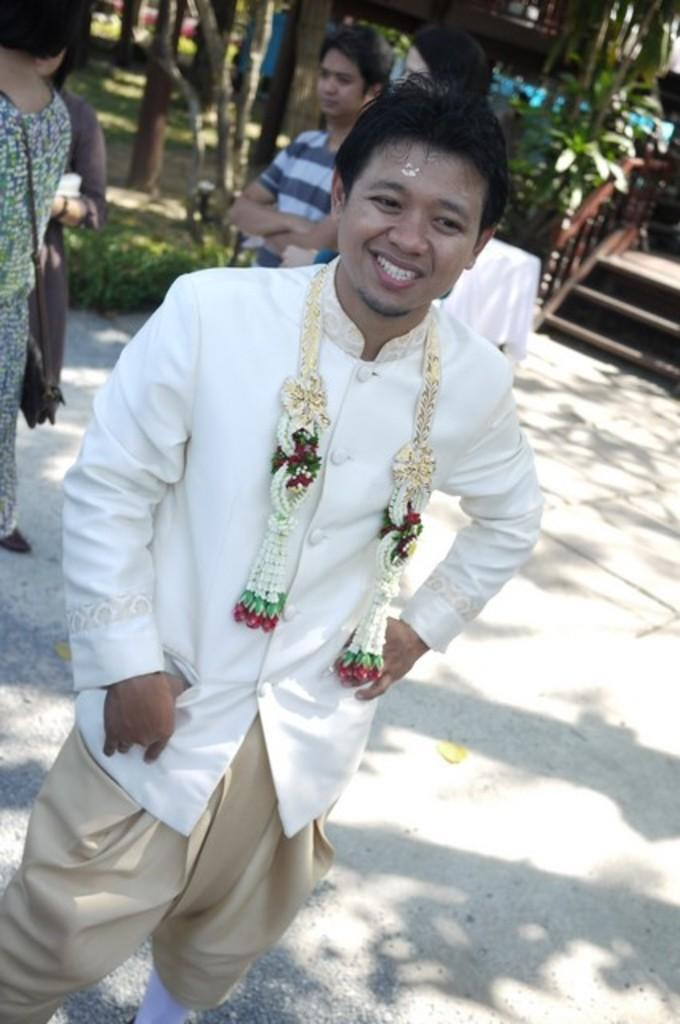What are the persons in the image wearing? The persons in the image are wearing clothes. What can be seen in the top right of the image? There is a staircase in the top right of the image. What type of objects are at the top of the image? There are stems at the top of the image. How does the heat affect the women in the image? There are no women or heat mentioned in the image, so it's not possible to determine how heat might affect them. What type of quiver is visible in the image? There is no quiver present in the image. 